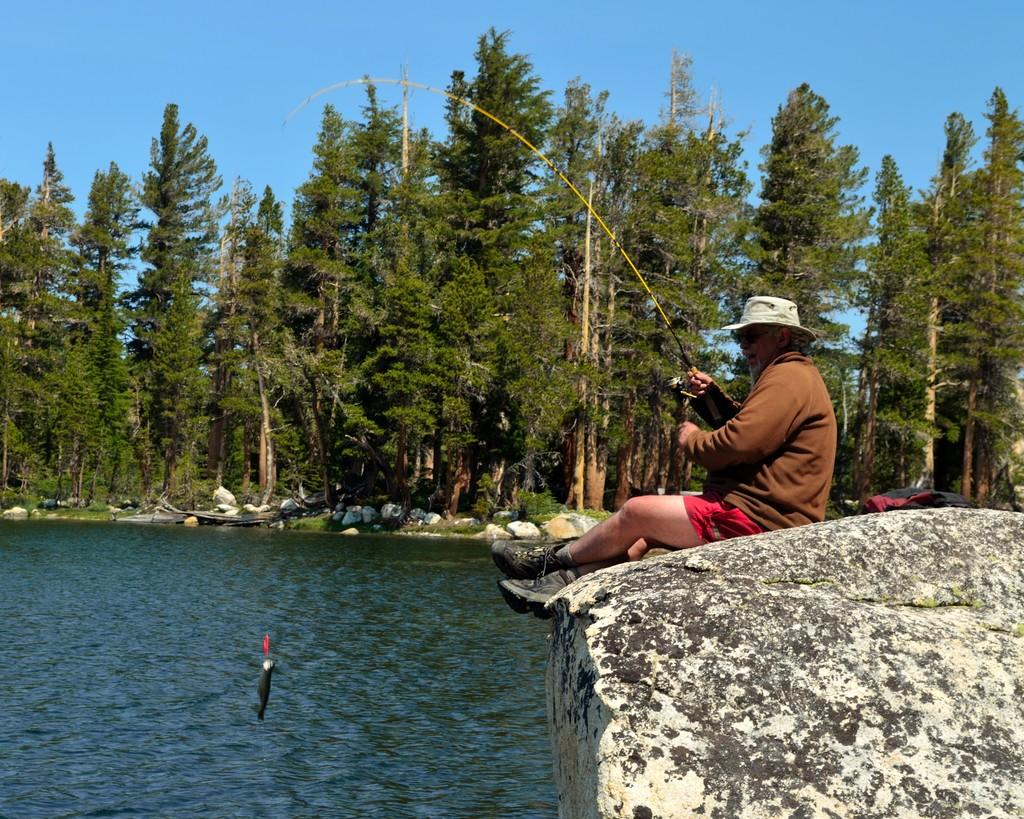What is the man doing in the image? The man is sitting on a rock in the image. What is the man holding in the image? The man is holding a fishing rod in the image. Can you describe the fish in the image? There is a fish in the image. What can be seen in the background of the image? There are trees, rocks, and the sky visible in the background of the image. What color are the man's toes in the image? There is no indication of the man's toes in the image, as he is sitting on a rock and wearing shoes. 